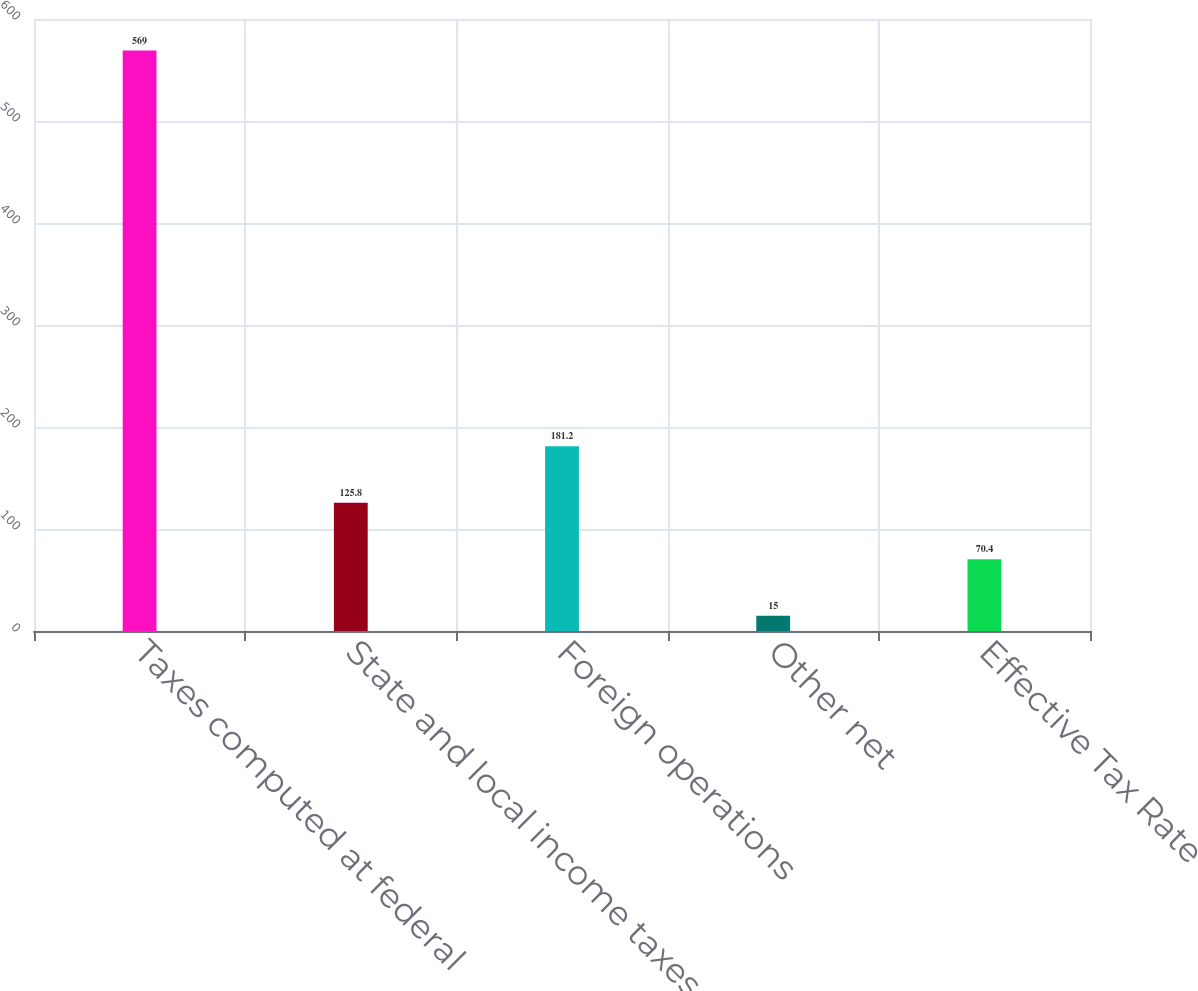Convert chart to OTSL. <chart><loc_0><loc_0><loc_500><loc_500><bar_chart><fcel>Taxes computed at federal<fcel>State and local income taxes<fcel>Foreign operations<fcel>Other net<fcel>Effective Tax Rate<nl><fcel>569<fcel>125.8<fcel>181.2<fcel>15<fcel>70.4<nl></chart> 